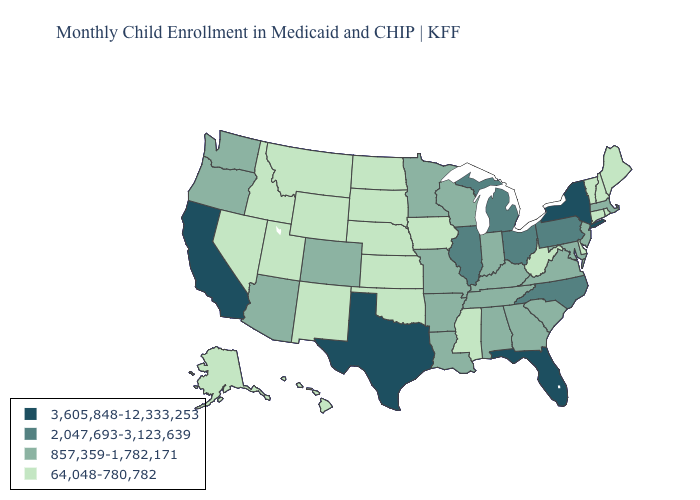Among the states that border Vermont , does Massachusetts have the highest value?
Concise answer only. No. Does the first symbol in the legend represent the smallest category?
Give a very brief answer. No. Name the states that have a value in the range 2,047,693-3,123,639?
Keep it brief. Illinois, Michigan, North Carolina, Ohio, Pennsylvania. Does the map have missing data?
Be succinct. No. What is the lowest value in the West?
Give a very brief answer. 64,048-780,782. Which states have the lowest value in the MidWest?
Give a very brief answer. Iowa, Kansas, Nebraska, North Dakota, South Dakota. Among the states that border Missouri , which have the highest value?
Give a very brief answer. Illinois. What is the value of New Jersey?
Be succinct. 857,359-1,782,171. Does California have the same value as Hawaii?
Give a very brief answer. No. Does California have the lowest value in the USA?
Be succinct. No. What is the lowest value in the USA?
Keep it brief. 64,048-780,782. What is the value of Washington?
Short answer required. 857,359-1,782,171. What is the value of Maine?
Give a very brief answer. 64,048-780,782. Does Connecticut have a lower value than Wisconsin?
Answer briefly. Yes. 